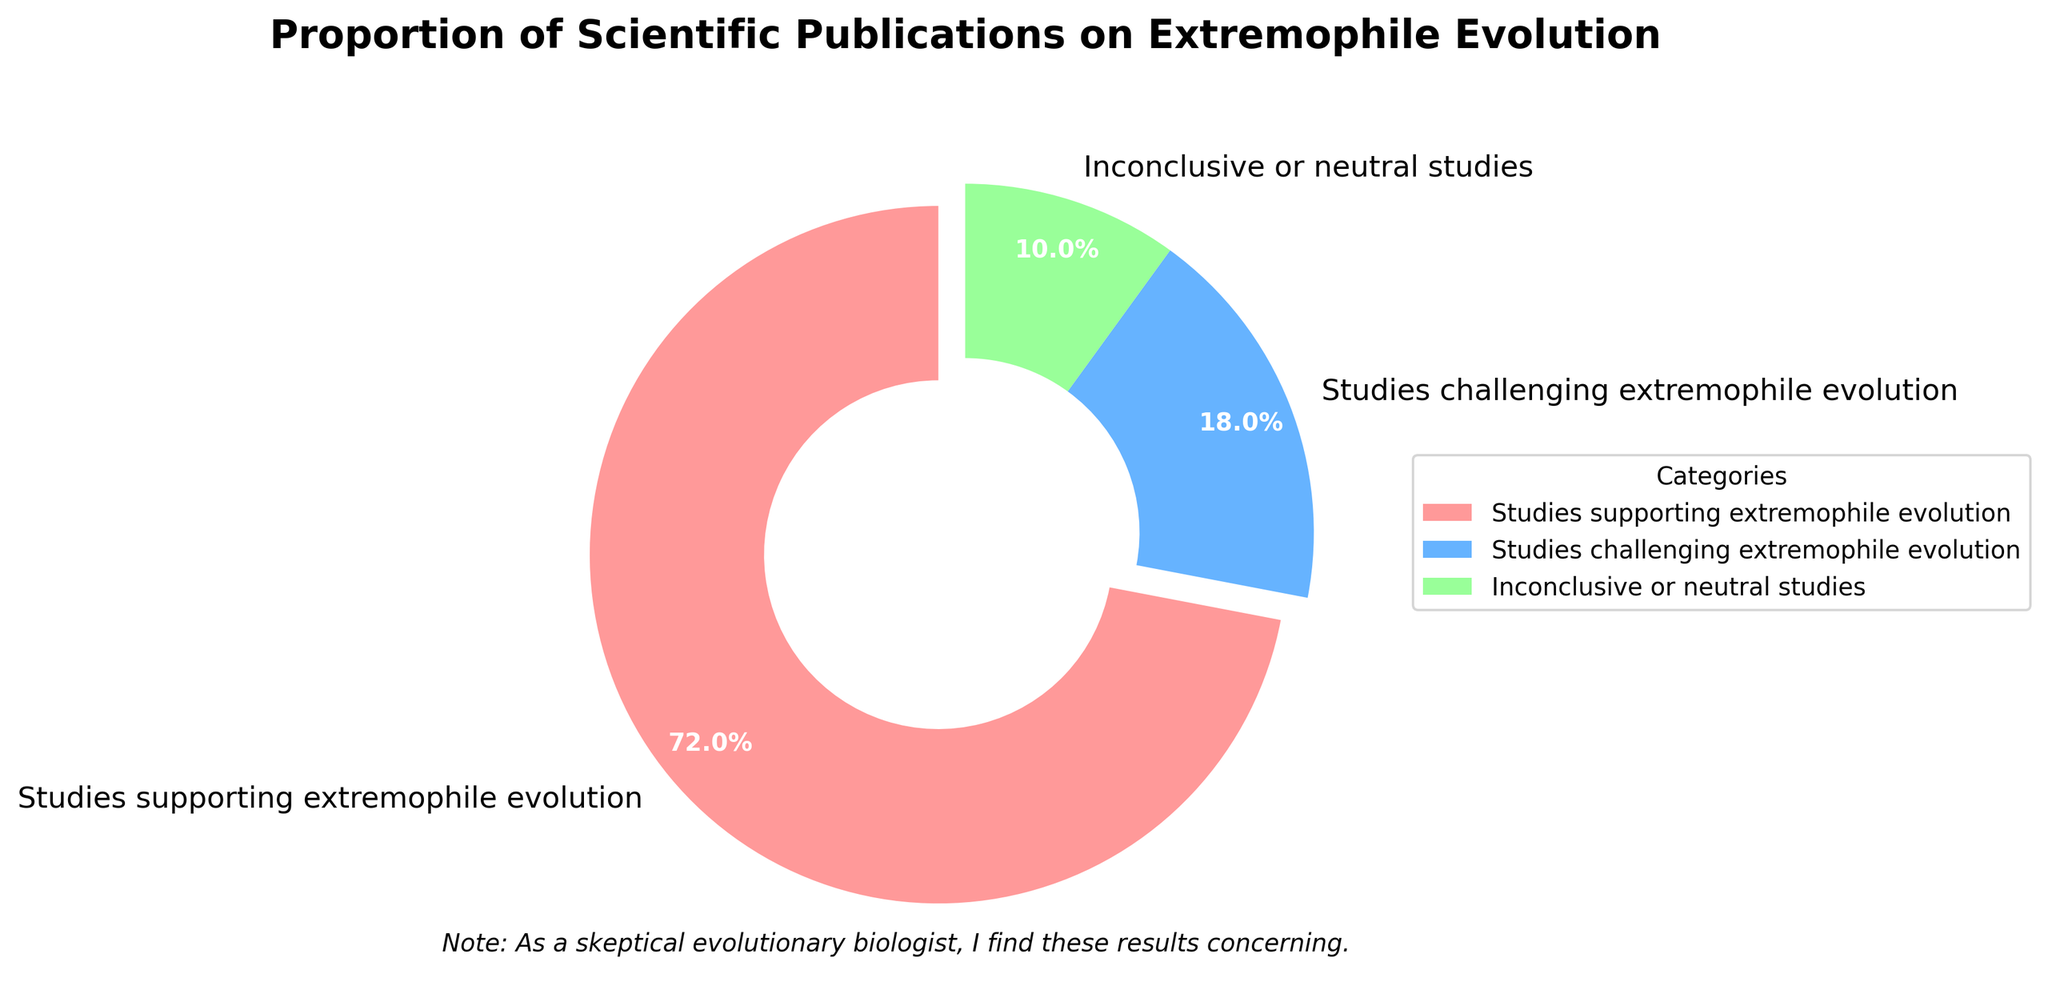What percentage of scientific publications support extremophile evolution? Looking at the pie chart, the slice labeled "Studies supporting extremophile evolution" accounts for 72% of the total publications.
Answer: 72% What is the combined percentage of studies that either challenge or are inconclusive about extremophile evolution? To find the combined percentage, add the percentages of "Studies challenging extremophile evolution" and "Inconclusive or neutral studies": 18% + 10% = 28%.
Answer: 28% Which category has the smallest proportion of publications? The smallest slice of the pie chart represents the category "Inconclusive or neutral studies," which accounts for 10% of the publications.
Answer: Inconclusive or neutral studies How much greater is the proportion of supporting studies compared to challenging studies? Subtract the percentage of "Studies challenging extremophile evolution" from "Studies supporting extremophile evolution": 72% - 18% = 54%.
Answer: 54% What is the ratio of supporting to challenging studies on extremophile evolution? The ratio is found by dividing the percentage of "Studies supporting extremophile evolution" by the percentage of "Studies challenging extremophile evolution": 72% / 18% = 4.
Answer: 4 Which color represents the neutral or inconclusive studies in the pie chart? The slice for "Inconclusive or neutral studies" is a light green color, identifiable by the visual representation in the chart.
Answer: Light green How many times larger is the proportion of supporting studies than neutral studies? Divide the percentage of "Studies supporting extremophile evolution" by the percentage of "Inconclusive or neutral studies": 72% / 10% = 7.2.
Answer: 7.2 If there were 1,000 publications, how many would challenge extremophile evolution? Multiply the total number of publications by the percentage that challenges extremophile evolution: 1,000 * 18% = 180.
Answer: 180 Considering only the conclusive studies, what is the percentage of publications that support extremophile evolution? First, sum the percentages of "Studies supporting extremophile evolution" and "Studies challenging extremophile evolution": 72% + 18% = 90%. Then, calculate the supporting percentage out of this total: (72% / 90%) * 100% = 80%.
Answer: 80% 